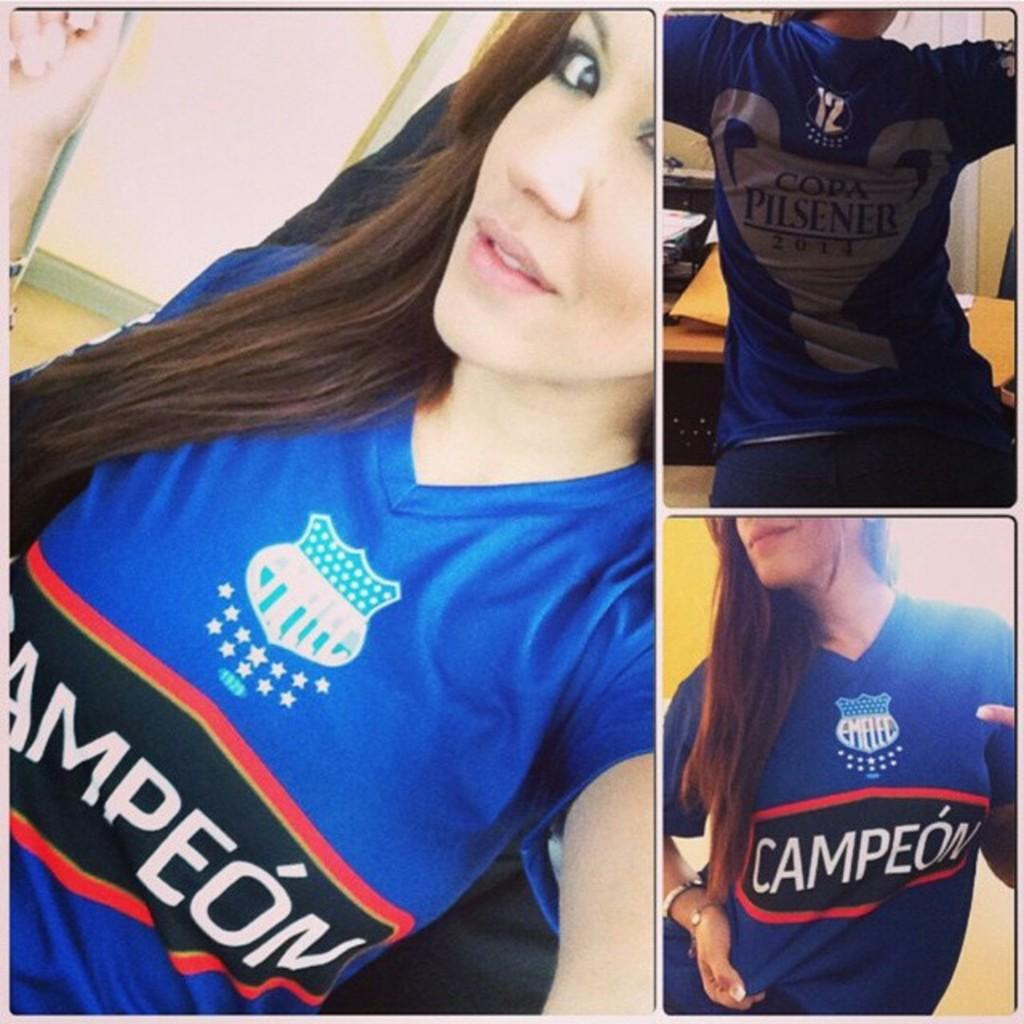<image>
Describe the image concisely. A lady wearing a Campeon #12 jersey poses in a collage of pictures. 